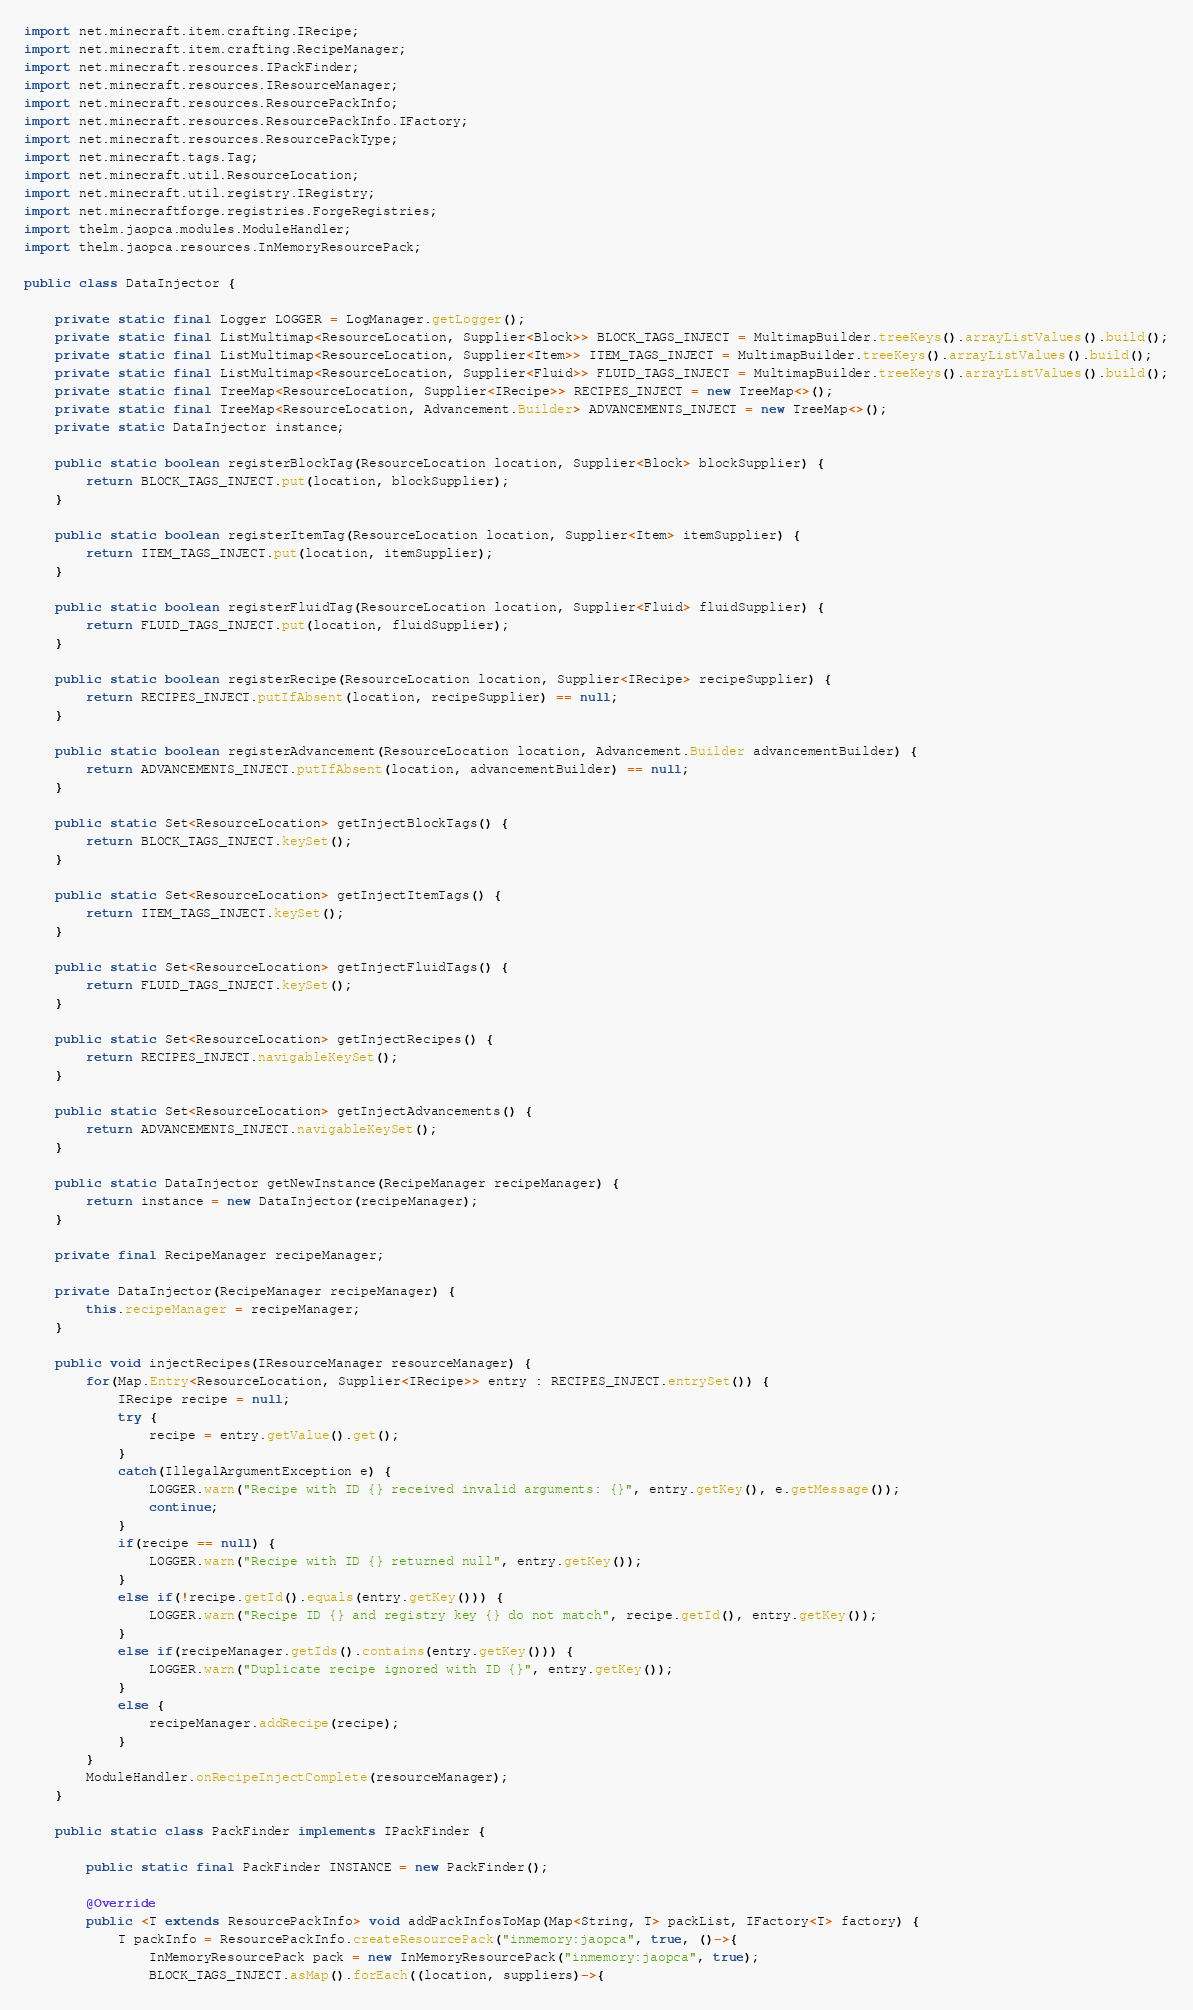<code> <loc_0><loc_0><loc_500><loc_500><_Java_>import net.minecraft.item.crafting.IRecipe;
import net.minecraft.item.crafting.RecipeManager;
import net.minecraft.resources.IPackFinder;
import net.minecraft.resources.IResourceManager;
import net.minecraft.resources.ResourcePackInfo;
import net.minecraft.resources.ResourcePackInfo.IFactory;
import net.minecraft.resources.ResourcePackType;
import net.minecraft.tags.Tag;
import net.minecraft.util.ResourceLocation;
import net.minecraft.util.registry.IRegistry;
import net.minecraftforge.registries.ForgeRegistries;
import thelm.jaopca.modules.ModuleHandler;
import thelm.jaopca.resources.InMemoryResourcePack;

public class DataInjector {

	private static final Logger LOGGER = LogManager.getLogger();
	private static final ListMultimap<ResourceLocation, Supplier<Block>> BLOCK_TAGS_INJECT = MultimapBuilder.treeKeys().arrayListValues().build();
	private static final ListMultimap<ResourceLocation, Supplier<Item>> ITEM_TAGS_INJECT = MultimapBuilder.treeKeys().arrayListValues().build();
	private static final ListMultimap<ResourceLocation, Supplier<Fluid>> FLUID_TAGS_INJECT = MultimapBuilder.treeKeys().arrayListValues().build();
	private static final TreeMap<ResourceLocation, Supplier<IRecipe>> RECIPES_INJECT = new TreeMap<>();
	private static final TreeMap<ResourceLocation, Advancement.Builder> ADVANCEMENTS_INJECT = new TreeMap<>();
	private static DataInjector instance;

	public static boolean registerBlockTag(ResourceLocation location, Supplier<Block> blockSupplier) {
		return BLOCK_TAGS_INJECT.put(location, blockSupplier);
	}

	public static boolean registerItemTag(ResourceLocation location, Supplier<Item> itemSupplier) {
		return ITEM_TAGS_INJECT.put(location, itemSupplier);
	}

	public static boolean registerFluidTag(ResourceLocation location, Supplier<Fluid> fluidSupplier) {
		return FLUID_TAGS_INJECT.put(location, fluidSupplier);
	}

	public static boolean registerRecipe(ResourceLocation location, Supplier<IRecipe> recipeSupplier) {
		return RECIPES_INJECT.putIfAbsent(location, recipeSupplier) == null;
	}

	public static boolean registerAdvancement(ResourceLocation location, Advancement.Builder advancementBuilder) {
		return ADVANCEMENTS_INJECT.putIfAbsent(location, advancementBuilder) == null;
	}

	public static Set<ResourceLocation> getInjectBlockTags() {
		return BLOCK_TAGS_INJECT.keySet();
	}

	public static Set<ResourceLocation> getInjectItemTags() {
		return ITEM_TAGS_INJECT.keySet();
	}

	public static Set<ResourceLocation> getInjectFluidTags() {
		return FLUID_TAGS_INJECT.keySet();
	}

	public static Set<ResourceLocation> getInjectRecipes() {
		return RECIPES_INJECT.navigableKeySet();
	}

	public static Set<ResourceLocation> getInjectAdvancements() {
		return ADVANCEMENTS_INJECT.navigableKeySet();
	}

	public static DataInjector getNewInstance(RecipeManager recipeManager) {
		return instance = new DataInjector(recipeManager);
	}

	private final RecipeManager recipeManager;

	private DataInjector(RecipeManager recipeManager) {
		this.recipeManager = recipeManager;
	}

	public void injectRecipes(IResourceManager resourceManager) {
		for(Map.Entry<ResourceLocation, Supplier<IRecipe>> entry : RECIPES_INJECT.entrySet()) {
			IRecipe recipe = null;
			try {
				recipe = entry.getValue().get();
			}
			catch(IllegalArgumentException e) {
				LOGGER.warn("Recipe with ID {} received invalid arguments: {}", entry.getKey(), e.getMessage());
				continue;
			}
			if(recipe == null) {
				LOGGER.warn("Recipe with ID {} returned null", entry.getKey());
			}
			else if(!recipe.getId().equals(entry.getKey())) {
				LOGGER.warn("Recipe ID {} and registry key {} do not match", recipe.getId(), entry.getKey());
			}
			else if(recipeManager.getIds().contains(entry.getKey())) {
				LOGGER.warn("Duplicate recipe ignored with ID {}", entry.getKey());
			}
			else {
				recipeManager.addRecipe(recipe);
			}
		}
		ModuleHandler.onRecipeInjectComplete(resourceManager);
	}

	public static class PackFinder implements IPackFinder {

		public static final PackFinder INSTANCE = new PackFinder();

		@Override
		public <T extends ResourcePackInfo> void addPackInfosToMap(Map<String, T> packList, IFactory<T> factory) {
			T packInfo = ResourcePackInfo.createResourcePack("inmemory:jaopca", true, ()->{
				InMemoryResourcePack pack = new InMemoryResourcePack("inmemory:jaopca", true);
				BLOCK_TAGS_INJECT.asMap().forEach((location, suppliers)->{</code> 